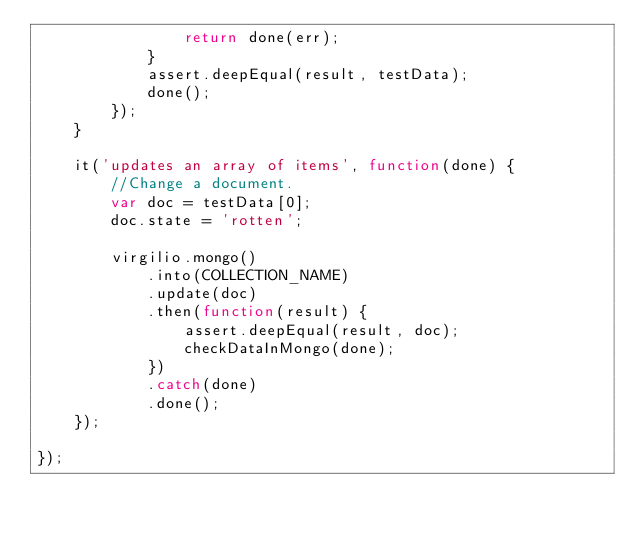Convert code to text. <code><loc_0><loc_0><loc_500><loc_500><_JavaScript_>                return done(err);
            }
            assert.deepEqual(result, testData);
            done();
        });
    }

    it('updates an array of items', function(done) {
        //Change a document.
        var doc = testData[0];
        doc.state = 'rotten';

        virgilio.mongo()
            .into(COLLECTION_NAME)
            .update(doc)
            .then(function(result) {
                assert.deepEqual(result, doc);
                checkDataInMongo(done);
            })
            .catch(done)
            .done();
    });

});
</code> 